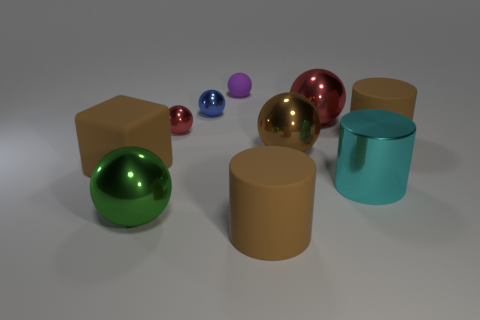Subtract all matte cylinders. How many cylinders are left? 1 Subtract all purple balls. How many balls are left? 5 Subtract all green spheres. Subtract all yellow cylinders. How many spheres are left? 5 Subtract all cubes. How many objects are left? 9 Subtract all blocks. Subtract all blue shiny cylinders. How many objects are left? 9 Add 7 large brown blocks. How many large brown blocks are left? 8 Add 3 big brown rubber cubes. How many big brown rubber cubes exist? 4 Subtract 0 gray blocks. How many objects are left? 10 